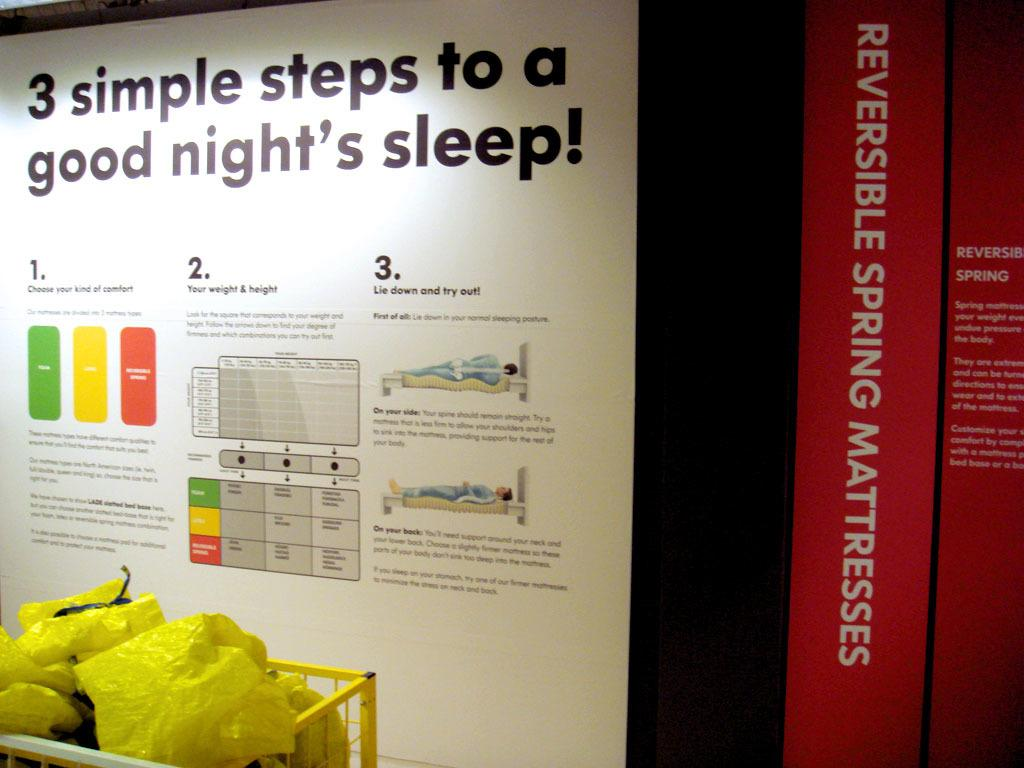<image>
Summarize the visual content of the image. A poster advises you on 3 simple steps to a good night's sleep! 